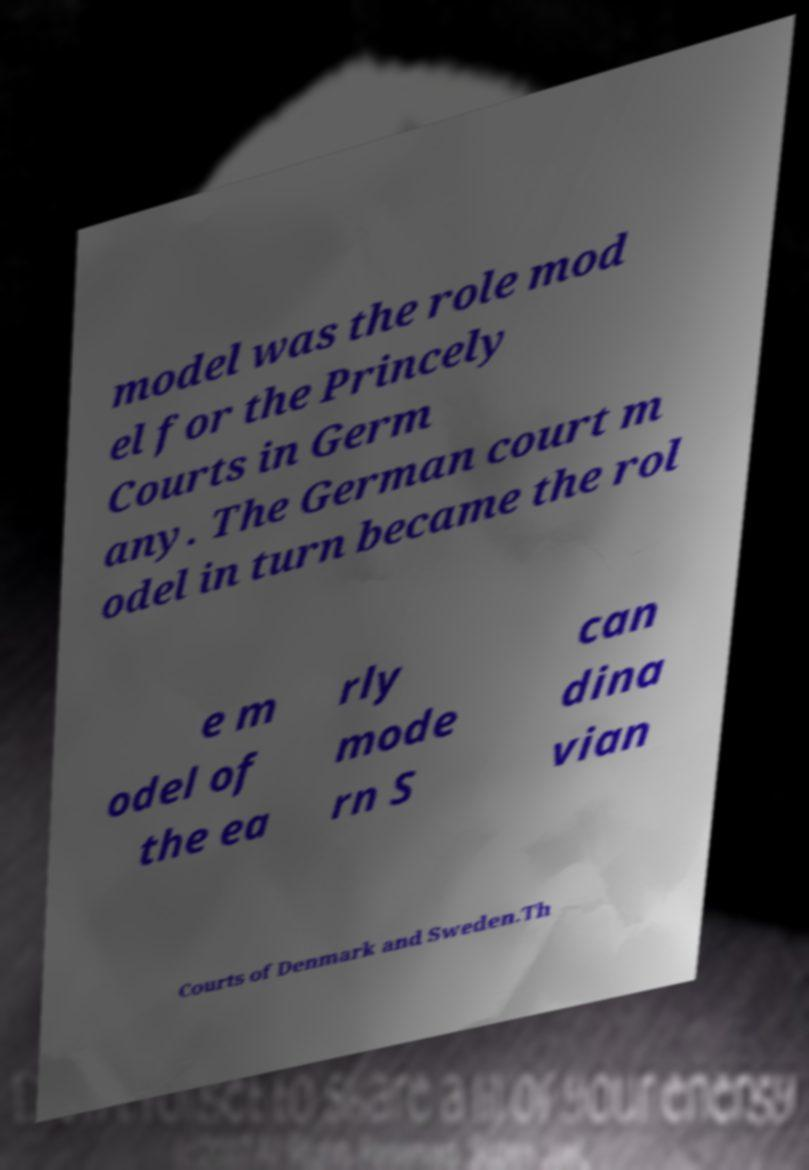Can you accurately transcribe the text from the provided image for me? model was the role mod el for the Princely Courts in Germ any. The German court m odel in turn became the rol e m odel of the ea rly mode rn S can dina vian Courts of Denmark and Sweden.Th 